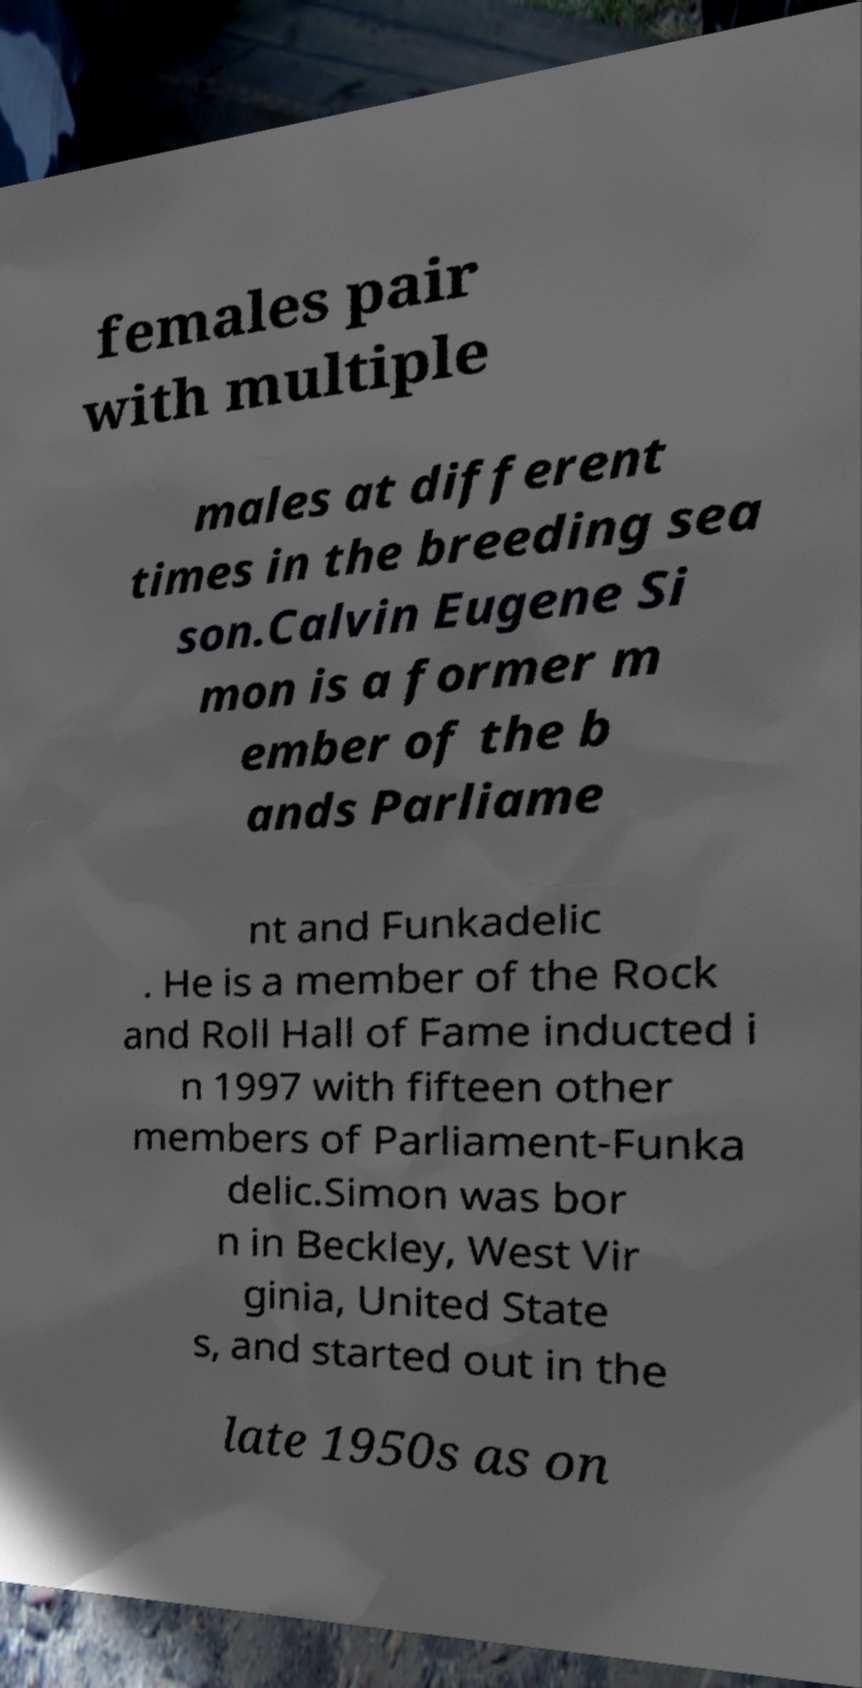Can you accurately transcribe the text from the provided image for me? females pair with multiple males at different times in the breeding sea son.Calvin Eugene Si mon is a former m ember of the b ands Parliame nt and Funkadelic . He is a member of the Rock and Roll Hall of Fame inducted i n 1997 with fifteen other members of Parliament-Funka delic.Simon was bor n in Beckley, West Vir ginia, United State s, and started out in the late 1950s as on 